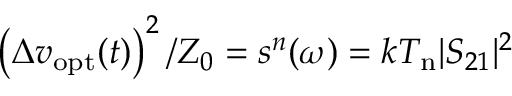Convert formula to latex. <formula><loc_0><loc_0><loc_500><loc_500>\left ( \Delta v _ { o p t } ( t ) \right ) ^ { 2 } / Z _ { 0 } = s ^ { n } ( \omega ) = k T _ { n } | S _ { 2 1 } | ^ { 2 }</formula> 